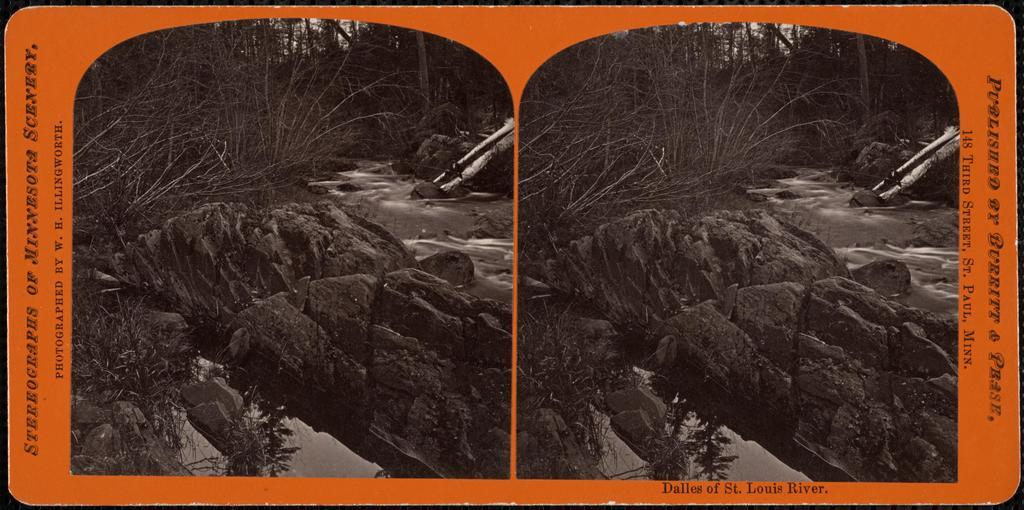What type of artwork is the image? The image is a collage. What natural elements can be seen in the image? There are rocks and trees visible in the image. What is the water element in the image? There is water visible in the image. What man-made object with words is present in the image? There is an orange object with words written on it in the image. What type of punishment is being depicted in the image? There is no punishment being depicted in the image; it is a collage featuring rocks, trees, water, and an orange object with words. Can you see a fireman in the image? There is no fireman present in the image. 